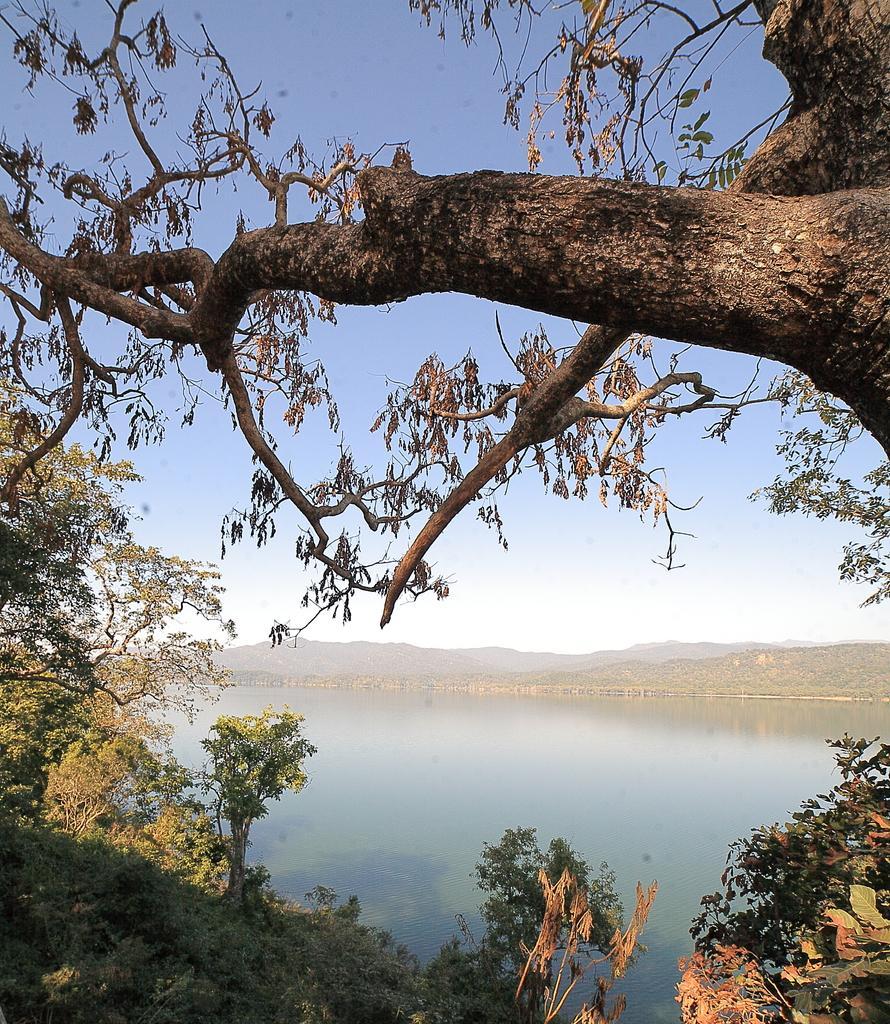How would you summarize this image in a sentence or two? In this picture I can see the trees in front and in the middle of this picture I see the water and in the background I see the sky. 